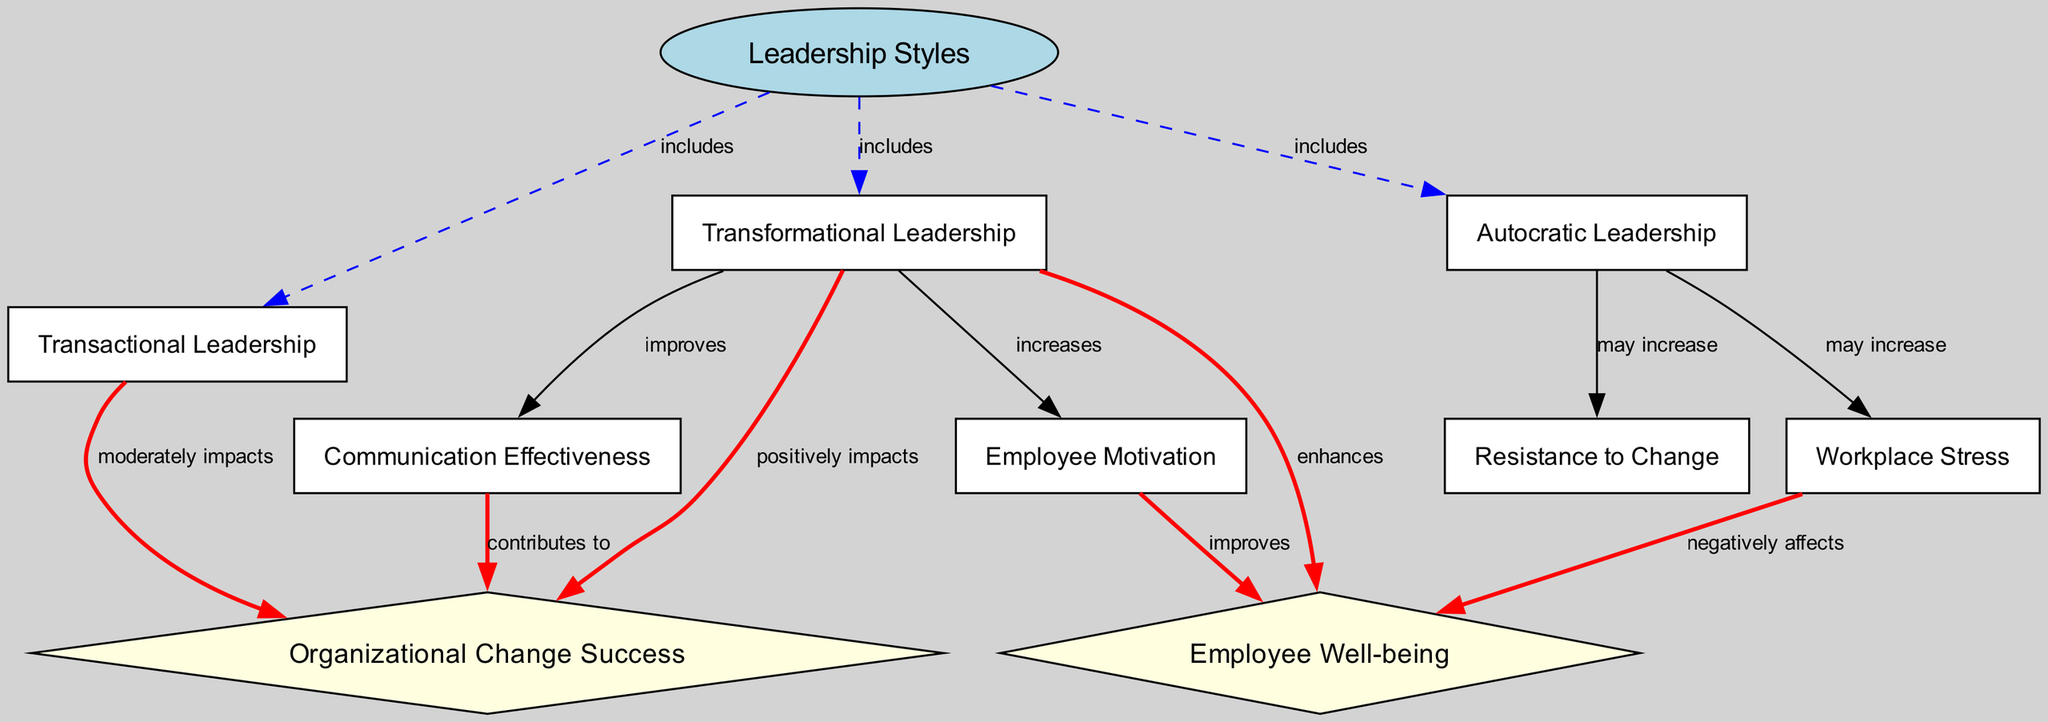What are the three types of leadership styles included in the diagram? The diagram contains three nodes under "Leadership Styles": Transformational Leadership, Transactional Leadership, and Autocratic Leadership. By counting the edges labeled "includes" from the "Leadership Styles" node, we identify these three specific types.
Answer: Transformational Leadership, Transactional Leadership, Autocratic Leadership Which leadership style positively impacts organizational change success? The diagram indicates a direct edge from "Transformational Leadership" to "Organizational Change Success" labeled "positively impacts," confirming this leadership style's influence.
Answer: Transformational Leadership How does communication effectiveness relate to organizational change success? According to the diagram, "Communication Effectiveness" has a direct edge labeled "contributes to" leading to "Organizational Change Success," meaning that effective communication is essential for successful organizational change.
Answer: Contributes to Which leadership style may increase resistance to change? The diagram shows a connection where "Autocratic Leadership" leads to "Resistance to Change," with an edge labeled "may increase." This indicates that this leadership style is likely to foster resistance when changes are implemented.
Answer: Autocratic Leadership What is the relationship between transformational leadership and employee motivation? The diagram illustrates that "Transformational Leadership" directly increases "Employee Motivation," with an edge labeled "increases." This indicates that transformational leaders are effective in motivating employees.
Answer: Increases What negative effect is caused by stress according to the diagram? The diagram shows an edge from "Workplace Stress" to "Employee Well-being" labeled "negatively affects," clearly identifying that increased stress leads to diminished well-being of employees.
Answer: Negatively affects Identify the impact of transactional leadership on organizational change success. The diagram indicates that "Transactional Leadership" has a moderate impact on "Organizational Change Success," demonstrated by the edge labeled "moderately impacts" that connects the two nodes.
Answer: Moderately impacts How does transformational leadership enhance employee well-being? The diagram reveals a direct edge from "Transformational Leadership" to "Employee Well-being" labeled "enhances," indicating this specific leadership style improves overall employee well-being during organizational changes.
Answer: Enhances Which factors contribute to increased employee well-being? Through a network of connections, the diagram links "Motivation" which is increased by "Transformational Leadership" and directly improves "Employee Well-being." This chain illustrates that motivation positively influences well-being.
Answer: Motivation 